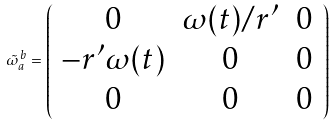<formula> <loc_0><loc_0><loc_500><loc_500>\tilde { \omega } _ { a } ^ { \, b } = \left ( \begin{array} { c c c } 0 & \omega ( t ) / r ^ { \prime } & 0 \\ - r ^ { \prime } \omega ( t ) & 0 & 0 \\ 0 & 0 & 0 \end{array} \right )</formula> 